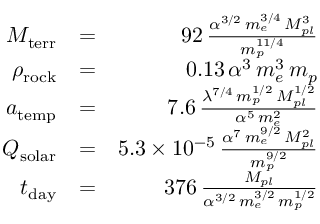Convert formula to latex. <formula><loc_0><loc_0><loc_500><loc_500>\begin{array} { r l r } { M _ { t e r r } } & { = } & { 9 2 \, \frac { \alpha ^ { 3 / 2 } \, m _ { e } ^ { 3 / 4 } \, M _ { p l } ^ { 3 } } { m _ { p } ^ { 1 1 / 4 } } } \\ { \rho _ { r o c k } } & { = } & { 0 . 1 3 \, \alpha ^ { 3 } \, m _ { e } ^ { 3 } \, m _ { p } } \\ { a _ { t e m p } } & { = } & { 7 . 6 \, \frac { \lambda ^ { 7 / 4 } \, m _ { p } ^ { 1 / 2 } \, M _ { p l } ^ { 1 / 2 } } { \alpha ^ { 5 } \, m _ { e } ^ { 2 } } } \\ { Q _ { s o l a r } } & { = } & { 5 . 3 \times 1 0 ^ { - 5 } \, \frac { \alpha ^ { 7 } \, m _ { e } ^ { 9 / 2 } \, M _ { p l } ^ { 2 } } { m _ { p } ^ { 9 / 2 } } } \\ { t _ { d a y } } & { = } & { 3 7 6 \, \frac { M _ { p l } } { \alpha ^ { 3 / 2 } \, m _ { e } ^ { 3 / 2 } \, m _ { p } ^ { 1 / 2 } } } \end{array}</formula> 